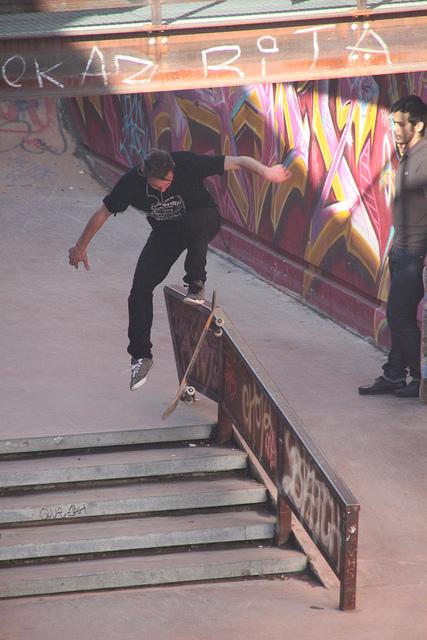How many steps is there?
Quick response, please. 5. Is the man falling?
Quick response, please. No. What is the man doing?
Quick response, please. Skateboarding. 